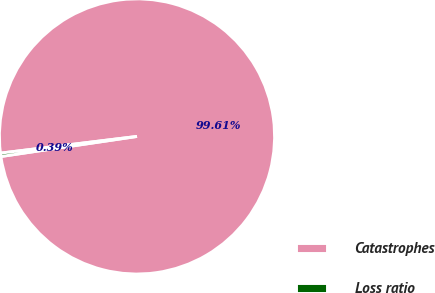<chart> <loc_0><loc_0><loc_500><loc_500><pie_chart><fcel>Catastrophes<fcel>Loss ratio<nl><fcel>99.61%<fcel>0.39%<nl></chart> 